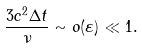<formula> <loc_0><loc_0><loc_500><loc_500>\frac { 3 c ^ { 2 } \Delta t } { \nu } \sim o ( \varepsilon ) \ll 1 .</formula> 